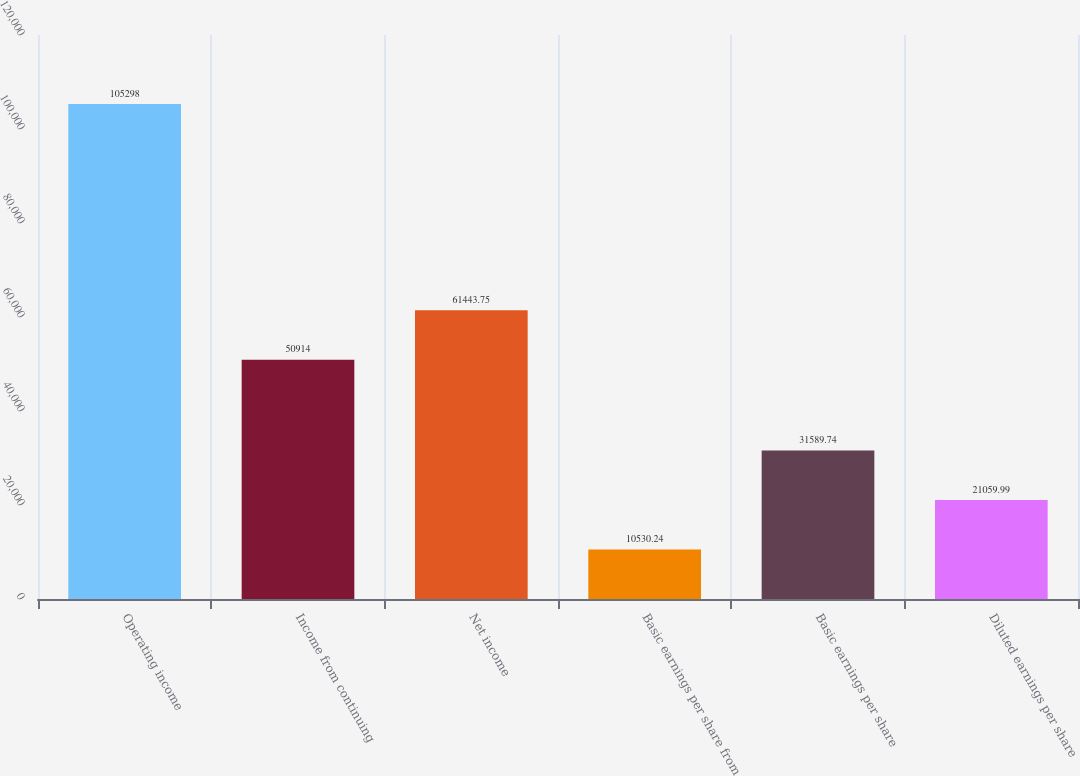Convert chart. <chart><loc_0><loc_0><loc_500><loc_500><bar_chart><fcel>Operating income<fcel>Income from continuing<fcel>Net income<fcel>Basic earnings per share from<fcel>Basic earnings per share<fcel>Diluted earnings per share<nl><fcel>105298<fcel>50914<fcel>61443.8<fcel>10530.2<fcel>31589.7<fcel>21060<nl></chart> 